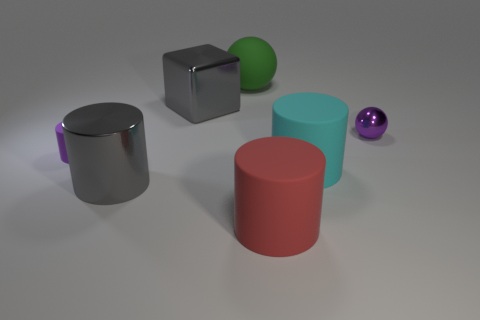What is the shape of the green matte object?
Make the answer very short. Sphere. Is there a big cylinder on the left side of the small purple object that is to the left of the green ball?
Offer a terse response. No. There is a tiny purple object to the left of the cyan matte thing; what number of tiny cylinders are on the right side of it?
Offer a very short reply. 0. There is a thing that is the same size as the purple cylinder; what material is it?
Give a very brief answer. Metal. There is a gray metal object that is behind the cyan matte cylinder; is it the same shape as the small purple metallic thing?
Offer a very short reply. No. Are there more large cyan matte cylinders that are behind the large gray metallic cube than big gray shiny things in front of the big cyan rubber cylinder?
Give a very brief answer. No. What number of large blocks have the same material as the big cyan thing?
Offer a very short reply. 0. Do the green sphere and the cube have the same size?
Make the answer very short. Yes. What is the color of the big ball?
Your answer should be very brief. Green. What number of objects are either red matte blocks or purple shiny things?
Your response must be concise. 1. 